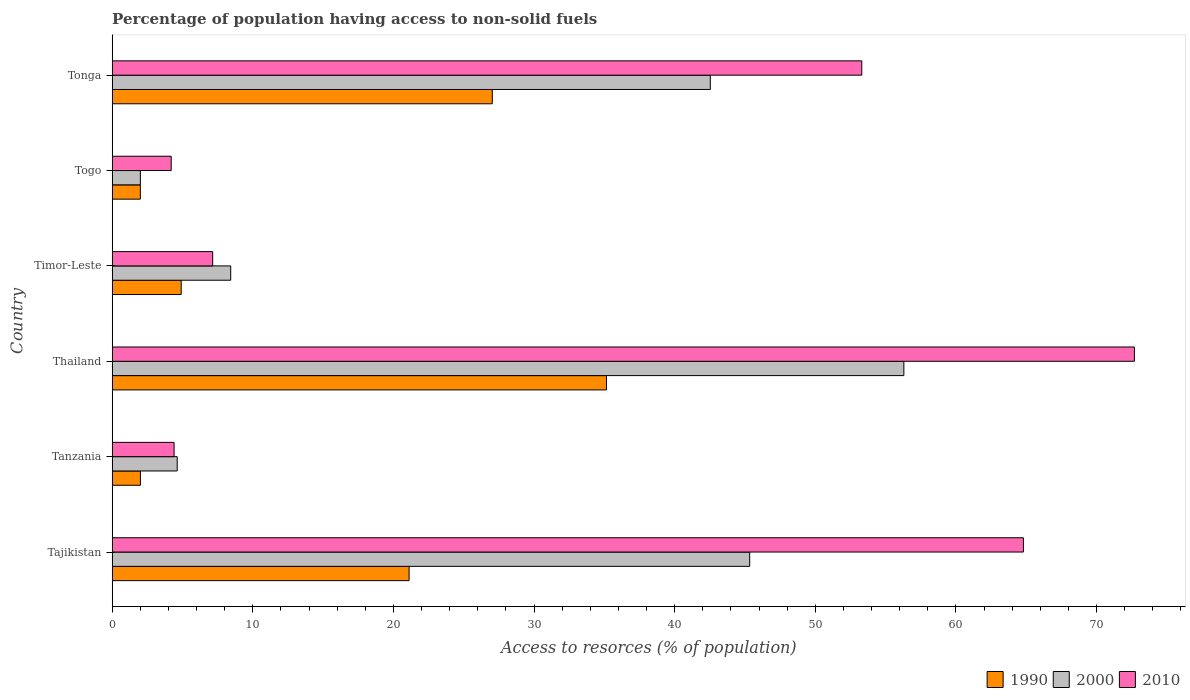How many different coloured bars are there?
Offer a terse response. 3. How many bars are there on the 3rd tick from the top?
Your response must be concise. 3. How many bars are there on the 1st tick from the bottom?
Provide a succinct answer. 3. What is the label of the 5th group of bars from the top?
Give a very brief answer. Tanzania. In how many cases, is the number of bars for a given country not equal to the number of legend labels?
Ensure brevity in your answer.  0. What is the percentage of population having access to non-solid fuels in 2000 in Tonga?
Your response must be concise. 42.54. Across all countries, what is the maximum percentage of population having access to non-solid fuels in 2010?
Make the answer very short. 72.7. Across all countries, what is the minimum percentage of population having access to non-solid fuels in 1990?
Offer a terse response. 2. In which country was the percentage of population having access to non-solid fuels in 1990 maximum?
Your answer should be very brief. Thailand. In which country was the percentage of population having access to non-solid fuels in 2000 minimum?
Keep it short and to the point. Togo. What is the total percentage of population having access to non-solid fuels in 1990 in the graph?
Offer a terse response. 92.2. What is the difference between the percentage of population having access to non-solid fuels in 2010 in Thailand and that in Timor-Leste?
Ensure brevity in your answer.  65.55. What is the difference between the percentage of population having access to non-solid fuels in 1990 in Togo and the percentage of population having access to non-solid fuels in 2000 in Tajikistan?
Provide a succinct answer. -43.34. What is the average percentage of population having access to non-solid fuels in 1990 per country?
Give a very brief answer. 15.37. What is the difference between the percentage of population having access to non-solid fuels in 2000 and percentage of population having access to non-solid fuels in 1990 in Tonga?
Keep it short and to the point. 15.51. In how many countries, is the percentage of population having access to non-solid fuels in 1990 greater than 2 %?
Provide a succinct answer. 5. What is the ratio of the percentage of population having access to non-solid fuels in 2010 in Thailand to that in Togo?
Provide a short and direct response. 17.33. Is the percentage of population having access to non-solid fuels in 2000 in Tajikistan less than that in Tonga?
Your answer should be very brief. No. What is the difference between the highest and the second highest percentage of population having access to non-solid fuels in 1990?
Provide a short and direct response. 8.12. What is the difference between the highest and the lowest percentage of population having access to non-solid fuels in 2010?
Provide a short and direct response. 68.5. In how many countries, is the percentage of population having access to non-solid fuels in 2010 greater than the average percentage of population having access to non-solid fuels in 2010 taken over all countries?
Keep it short and to the point. 3. Is the sum of the percentage of population having access to non-solid fuels in 2000 in Tanzania and Tonga greater than the maximum percentage of population having access to non-solid fuels in 2010 across all countries?
Offer a terse response. No. Is it the case that in every country, the sum of the percentage of population having access to non-solid fuels in 2000 and percentage of population having access to non-solid fuels in 2010 is greater than the percentage of population having access to non-solid fuels in 1990?
Keep it short and to the point. Yes. How many bars are there?
Offer a terse response. 18. Are all the bars in the graph horizontal?
Ensure brevity in your answer.  Yes. What is the difference between two consecutive major ticks on the X-axis?
Keep it short and to the point. 10. Are the values on the major ticks of X-axis written in scientific E-notation?
Your answer should be compact. No. Does the graph contain grids?
Your answer should be compact. No. What is the title of the graph?
Offer a very short reply. Percentage of population having access to non-solid fuels. What is the label or title of the X-axis?
Keep it short and to the point. Access to resorces (% of population). What is the label or title of the Y-axis?
Offer a very short reply. Country. What is the Access to resorces (% of population) of 1990 in Tajikistan?
Offer a very short reply. 21.11. What is the Access to resorces (% of population) in 2000 in Tajikistan?
Offer a terse response. 45.34. What is the Access to resorces (% of population) in 2010 in Tajikistan?
Offer a very short reply. 64.8. What is the Access to resorces (% of population) in 1990 in Tanzania?
Your response must be concise. 2.01. What is the Access to resorces (% of population) of 2000 in Tanzania?
Keep it short and to the point. 4.62. What is the Access to resorces (% of population) in 2010 in Tanzania?
Provide a succinct answer. 4.4. What is the Access to resorces (% of population) of 1990 in Thailand?
Offer a terse response. 35.15. What is the Access to resorces (% of population) in 2000 in Thailand?
Make the answer very short. 56.3. What is the Access to resorces (% of population) in 2010 in Thailand?
Keep it short and to the point. 72.7. What is the Access to resorces (% of population) of 1990 in Timor-Leste?
Make the answer very short. 4.9. What is the Access to resorces (% of population) of 2000 in Timor-Leste?
Make the answer very short. 8.43. What is the Access to resorces (% of population) in 2010 in Timor-Leste?
Offer a terse response. 7.14. What is the Access to resorces (% of population) in 1990 in Togo?
Give a very brief answer. 2. What is the Access to resorces (% of population) in 2000 in Togo?
Keep it short and to the point. 2. What is the Access to resorces (% of population) in 2010 in Togo?
Give a very brief answer. 4.19. What is the Access to resorces (% of population) in 1990 in Tonga?
Your response must be concise. 27.03. What is the Access to resorces (% of population) in 2000 in Tonga?
Offer a very short reply. 42.54. What is the Access to resorces (% of population) in 2010 in Tonga?
Your answer should be very brief. 53.31. Across all countries, what is the maximum Access to resorces (% of population) of 1990?
Offer a terse response. 35.15. Across all countries, what is the maximum Access to resorces (% of population) in 2000?
Keep it short and to the point. 56.3. Across all countries, what is the maximum Access to resorces (% of population) of 2010?
Keep it short and to the point. 72.7. Across all countries, what is the minimum Access to resorces (% of population) of 1990?
Your answer should be compact. 2. Across all countries, what is the minimum Access to resorces (% of population) in 2000?
Your answer should be very brief. 2. Across all countries, what is the minimum Access to resorces (% of population) in 2010?
Your response must be concise. 4.19. What is the total Access to resorces (% of population) of 1990 in the graph?
Offer a terse response. 92.2. What is the total Access to resorces (% of population) in 2000 in the graph?
Keep it short and to the point. 159.22. What is the total Access to resorces (% of population) in 2010 in the graph?
Make the answer very short. 206.54. What is the difference between the Access to resorces (% of population) of 1990 in Tajikistan and that in Tanzania?
Provide a short and direct response. 19.11. What is the difference between the Access to resorces (% of population) of 2000 in Tajikistan and that in Tanzania?
Offer a very short reply. 40.72. What is the difference between the Access to resorces (% of population) of 2010 in Tajikistan and that in Tanzania?
Ensure brevity in your answer.  60.4. What is the difference between the Access to resorces (% of population) of 1990 in Tajikistan and that in Thailand?
Provide a short and direct response. -14.04. What is the difference between the Access to resorces (% of population) of 2000 in Tajikistan and that in Thailand?
Your response must be concise. -10.96. What is the difference between the Access to resorces (% of population) in 2010 in Tajikistan and that in Thailand?
Keep it short and to the point. -7.89. What is the difference between the Access to resorces (% of population) in 1990 in Tajikistan and that in Timor-Leste?
Give a very brief answer. 16.21. What is the difference between the Access to resorces (% of population) of 2000 in Tajikistan and that in Timor-Leste?
Your answer should be very brief. 36.91. What is the difference between the Access to resorces (% of population) in 2010 in Tajikistan and that in Timor-Leste?
Keep it short and to the point. 57.66. What is the difference between the Access to resorces (% of population) in 1990 in Tajikistan and that in Togo?
Offer a terse response. 19.11. What is the difference between the Access to resorces (% of population) of 2000 in Tajikistan and that in Togo?
Your response must be concise. 43.33. What is the difference between the Access to resorces (% of population) of 2010 in Tajikistan and that in Togo?
Your answer should be compact. 60.61. What is the difference between the Access to resorces (% of population) in 1990 in Tajikistan and that in Tonga?
Provide a succinct answer. -5.92. What is the difference between the Access to resorces (% of population) of 2000 in Tajikistan and that in Tonga?
Make the answer very short. 2.8. What is the difference between the Access to resorces (% of population) in 2010 in Tajikistan and that in Tonga?
Offer a very short reply. 11.5. What is the difference between the Access to resorces (% of population) in 1990 in Tanzania and that in Thailand?
Make the answer very short. -33.15. What is the difference between the Access to resorces (% of population) of 2000 in Tanzania and that in Thailand?
Your answer should be very brief. -51.68. What is the difference between the Access to resorces (% of population) of 2010 in Tanzania and that in Thailand?
Give a very brief answer. -68.3. What is the difference between the Access to resorces (% of population) in 1990 in Tanzania and that in Timor-Leste?
Give a very brief answer. -2.9. What is the difference between the Access to resorces (% of population) of 2000 in Tanzania and that in Timor-Leste?
Your answer should be very brief. -3.81. What is the difference between the Access to resorces (% of population) in 2010 in Tanzania and that in Timor-Leste?
Make the answer very short. -2.75. What is the difference between the Access to resorces (% of population) of 1990 in Tanzania and that in Togo?
Your response must be concise. 0.01. What is the difference between the Access to resorces (% of population) in 2000 in Tanzania and that in Togo?
Ensure brevity in your answer.  2.62. What is the difference between the Access to resorces (% of population) of 2010 in Tanzania and that in Togo?
Give a very brief answer. 0.2. What is the difference between the Access to resorces (% of population) of 1990 in Tanzania and that in Tonga?
Keep it short and to the point. -25.02. What is the difference between the Access to resorces (% of population) of 2000 in Tanzania and that in Tonga?
Make the answer very short. -37.92. What is the difference between the Access to resorces (% of population) in 2010 in Tanzania and that in Tonga?
Offer a terse response. -48.91. What is the difference between the Access to resorces (% of population) in 1990 in Thailand and that in Timor-Leste?
Provide a short and direct response. 30.25. What is the difference between the Access to resorces (% of population) of 2000 in Thailand and that in Timor-Leste?
Provide a short and direct response. 47.87. What is the difference between the Access to resorces (% of population) of 2010 in Thailand and that in Timor-Leste?
Offer a terse response. 65.55. What is the difference between the Access to resorces (% of population) in 1990 in Thailand and that in Togo?
Ensure brevity in your answer.  33.15. What is the difference between the Access to resorces (% of population) of 2000 in Thailand and that in Togo?
Provide a short and direct response. 54.3. What is the difference between the Access to resorces (% of population) of 2010 in Thailand and that in Togo?
Make the answer very short. 68.5. What is the difference between the Access to resorces (% of population) in 1990 in Thailand and that in Tonga?
Provide a short and direct response. 8.12. What is the difference between the Access to resorces (% of population) of 2000 in Thailand and that in Tonga?
Make the answer very short. 13.76. What is the difference between the Access to resorces (% of population) of 2010 in Thailand and that in Tonga?
Your answer should be compact. 19.39. What is the difference between the Access to resorces (% of population) of 1990 in Timor-Leste and that in Togo?
Offer a very short reply. 2.9. What is the difference between the Access to resorces (% of population) in 2000 in Timor-Leste and that in Togo?
Keep it short and to the point. 6.43. What is the difference between the Access to resorces (% of population) in 2010 in Timor-Leste and that in Togo?
Your answer should be very brief. 2.95. What is the difference between the Access to resorces (% of population) in 1990 in Timor-Leste and that in Tonga?
Keep it short and to the point. -22.13. What is the difference between the Access to resorces (% of population) in 2000 in Timor-Leste and that in Tonga?
Ensure brevity in your answer.  -34.11. What is the difference between the Access to resorces (% of population) in 2010 in Timor-Leste and that in Tonga?
Make the answer very short. -46.16. What is the difference between the Access to resorces (% of population) of 1990 in Togo and that in Tonga?
Your response must be concise. -25.03. What is the difference between the Access to resorces (% of population) of 2000 in Togo and that in Tonga?
Offer a terse response. -40.54. What is the difference between the Access to resorces (% of population) in 2010 in Togo and that in Tonga?
Your response must be concise. -49.11. What is the difference between the Access to resorces (% of population) in 1990 in Tajikistan and the Access to resorces (% of population) in 2000 in Tanzania?
Ensure brevity in your answer.  16.49. What is the difference between the Access to resorces (% of population) in 1990 in Tajikistan and the Access to resorces (% of population) in 2010 in Tanzania?
Your response must be concise. 16.71. What is the difference between the Access to resorces (% of population) of 2000 in Tajikistan and the Access to resorces (% of population) of 2010 in Tanzania?
Give a very brief answer. 40.94. What is the difference between the Access to resorces (% of population) of 1990 in Tajikistan and the Access to resorces (% of population) of 2000 in Thailand?
Provide a short and direct response. -35.19. What is the difference between the Access to resorces (% of population) of 1990 in Tajikistan and the Access to resorces (% of population) of 2010 in Thailand?
Offer a very short reply. -51.58. What is the difference between the Access to resorces (% of population) of 2000 in Tajikistan and the Access to resorces (% of population) of 2010 in Thailand?
Make the answer very short. -27.36. What is the difference between the Access to resorces (% of population) of 1990 in Tajikistan and the Access to resorces (% of population) of 2000 in Timor-Leste?
Make the answer very short. 12.69. What is the difference between the Access to resorces (% of population) in 1990 in Tajikistan and the Access to resorces (% of population) in 2010 in Timor-Leste?
Your response must be concise. 13.97. What is the difference between the Access to resorces (% of population) in 2000 in Tajikistan and the Access to resorces (% of population) in 2010 in Timor-Leste?
Offer a very short reply. 38.19. What is the difference between the Access to resorces (% of population) in 1990 in Tajikistan and the Access to resorces (% of population) in 2000 in Togo?
Provide a short and direct response. 19.11. What is the difference between the Access to resorces (% of population) in 1990 in Tajikistan and the Access to resorces (% of population) in 2010 in Togo?
Provide a succinct answer. 16.92. What is the difference between the Access to resorces (% of population) of 2000 in Tajikistan and the Access to resorces (% of population) of 2010 in Togo?
Offer a terse response. 41.14. What is the difference between the Access to resorces (% of population) of 1990 in Tajikistan and the Access to resorces (% of population) of 2000 in Tonga?
Offer a very short reply. -21.42. What is the difference between the Access to resorces (% of population) of 1990 in Tajikistan and the Access to resorces (% of population) of 2010 in Tonga?
Offer a terse response. -32.2. What is the difference between the Access to resorces (% of population) in 2000 in Tajikistan and the Access to resorces (% of population) in 2010 in Tonga?
Offer a very short reply. -7.97. What is the difference between the Access to resorces (% of population) in 1990 in Tanzania and the Access to resorces (% of population) in 2000 in Thailand?
Offer a very short reply. -54.3. What is the difference between the Access to resorces (% of population) in 1990 in Tanzania and the Access to resorces (% of population) in 2010 in Thailand?
Offer a terse response. -70.69. What is the difference between the Access to resorces (% of population) of 2000 in Tanzania and the Access to resorces (% of population) of 2010 in Thailand?
Your answer should be compact. -68.08. What is the difference between the Access to resorces (% of population) of 1990 in Tanzania and the Access to resorces (% of population) of 2000 in Timor-Leste?
Offer a terse response. -6.42. What is the difference between the Access to resorces (% of population) of 1990 in Tanzania and the Access to resorces (% of population) of 2010 in Timor-Leste?
Provide a succinct answer. -5.14. What is the difference between the Access to resorces (% of population) in 2000 in Tanzania and the Access to resorces (% of population) in 2010 in Timor-Leste?
Your answer should be compact. -2.52. What is the difference between the Access to resorces (% of population) in 1990 in Tanzania and the Access to resorces (% of population) in 2000 in Togo?
Provide a succinct answer. 0. What is the difference between the Access to resorces (% of population) in 1990 in Tanzania and the Access to resorces (% of population) in 2010 in Togo?
Keep it short and to the point. -2.19. What is the difference between the Access to resorces (% of population) in 2000 in Tanzania and the Access to resorces (% of population) in 2010 in Togo?
Provide a short and direct response. 0.43. What is the difference between the Access to resorces (% of population) in 1990 in Tanzania and the Access to resorces (% of population) in 2000 in Tonga?
Make the answer very short. -40.53. What is the difference between the Access to resorces (% of population) of 1990 in Tanzania and the Access to resorces (% of population) of 2010 in Tonga?
Your answer should be compact. -51.3. What is the difference between the Access to resorces (% of population) in 2000 in Tanzania and the Access to resorces (% of population) in 2010 in Tonga?
Give a very brief answer. -48.69. What is the difference between the Access to resorces (% of population) of 1990 in Thailand and the Access to resorces (% of population) of 2000 in Timor-Leste?
Provide a succinct answer. 26.72. What is the difference between the Access to resorces (% of population) of 1990 in Thailand and the Access to resorces (% of population) of 2010 in Timor-Leste?
Make the answer very short. 28.01. What is the difference between the Access to resorces (% of population) of 2000 in Thailand and the Access to resorces (% of population) of 2010 in Timor-Leste?
Offer a terse response. 49.16. What is the difference between the Access to resorces (% of population) in 1990 in Thailand and the Access to resorces (% of population) in 2000 in Togo?
Give a very brief answer. 33.15. What is the difference between the Access to resorces (% of population) of 1990 in Thailand and the Access to resorces (% of population) of 2010 in Togo?
Provide a succinct answer. 30.96. What is the difference between the Access to resorces (% of population) of 2000 in Thailand and the Access to resorces (% of population) of 2010 in Togo?
Provide a short and direct response. 52.11. What is the difference between the Access to resorces (% of population) in 1990 in Thailand and the Access to resorces (% of population) in 2000 in Tonga?
Make the answer very short. -7.39. What is the difference between the Access to resorces (% of population) of 1990 in Thailand and the Access to resorces (% of population) of 2010 in Tonga?
Your answer should be very brief. -18.16. What is the difference between the Access to resorces (% of population) in 2000 in Thailand and the Access to resorces (% of population) in 2010 in Tonga?
Provide a short and direct response. 2.99. What is the difference between the Access to resorces (% of population) in 1990 in Timor-Leste and the Access to resorces (% of population) in 2000 in Togo?
Give a very brief answer. 2.9. What is the difference between the Access to resorces (% of population) in 1990 in Timor-Leste and the Access to resorces (% of population) in 2010 in Togo?
Provide a succinct answer. 0.71. What is the difference between the Access to resorces (% of population) in 2000 in Timor-Leste and the Access to resorces (% of population) in 2010 in Togo?
Provide a succinct answer. 4.23. What is the difference between the Access to resorces (% of population) in 1990 in Timor-Leste and the Access to resorces (% of population) in 2000 in Tonga?
Your answer should be compact. -37.63. What is the difference between the Access to resorces (% of population) of 1990 in Timor-Leste and the Access to resorces (% of population) of 2010 in Tonga?
Provide a short and direct response. -48.4. What is the difference between the Access to resorces (% of population) of 2000 in Timor-Leste and the Access to resorces (% of population) of 2010 in Tonga?
Make the answer very short. -44.88. What is the difference between the Access to resorces (% of population) of 1990 in Togo and the Access to resorces (% of population) of 2000 in Tonga?
Your answer should be very brief. -40.54. What is the difference between the Access to resorces (% of population) of 1990 in Togo and the Access to resorces (% of population) of 2010 in Tonga?
Ensure brevity in your answer.  -51.31. What is the difference between the Access to resorces (% of population) of 2000 in Togo and the Access to resorces (% of population) of 2010 in Tonga?
Ensure brevity in your answer.  -51.31. What is the average Access to resorces (% of population) of 1990 per country?
Offer a terse response. 15.37. What is the average Access to resorces (% of population) of 2000 per country?
Offer a terse response. 26.54. What is the average Access to resorces (% of population) of 2010 per country?
Offer a very short reply. 34.42. What is the difference between the Access to resorces (% of population) in 1990 and Access to resorces (% of population) in 2000 in Tajikistan?
Provide a short and direct response. -24.22. What is the difference between the Access to resorces (% of population) of 1990 and Access to resorces (% of population) of 2010 in Tajikistan?
Your response must be concise. -43.69. What is the difference between the Access to resorces (% of population) in 2000 and Access to resorces (% of population) in 2010 in Tajikistan?
Ensure brevity in your answer.  -19.47. What is the difference between the Access to resorces (% of population) of 1990 and Access to resorces (% of population) of 2000 in Tanzania?
Your answer should be very brief. -2.62. What is the difference between the Access to resorces (% of population) in 1990 and Access to resorces (% of population) in 2010 in Tanzania?
Offer a terse response. -2.39. What is the difference between the Access to resorces (% of population) of 2000 and Access to resorces (% of population) of 2010 in Tanzania?
Your answer should be compact. 0.22. What is the difference between the Access to resorces (% of population) in 1990 and Access to resorces (% of population) in 2000 in Thailand?
Provide a succinct answer. -21.15. What is the difference between the Access to resorces (% of population) of 1990 and Access to resorces (% of population) of 2010 in Thailand?
Provide a succinct answer. -37.54. What is the difference between the Access to resorces (% of population) in 2000 and Access to resorces (% of population) in 2010 in Thailand?
Make the answer very short. -16.39. What is the difference between the Access to resorces (% of population) of 1990 and Access to resorces (% of population) of 2000 in Timor-Leste?
Provide a short and direct response. -3.52. What is the difference between the Access to resorces (% of population) of 1990 and Access to resorces (% of population) of 2010 in Timor-Leste?
Provide a succinct answer. -2.24. What is the difference between the Access to resorces (% of population) in 2000 and Access to resorces (% of population) in 2010 in Timor-Leste?
Make the answer very short. 1.28. What is the difference between the Access to resorces (% of population) of 1990 and Access to resorces (% of population) of 2000 in Togo?
Provide a succinct answer. -0. What is the difference between the Access to resorces (% of population) in 1990 and Access to resorces (% of population) in 2010 in Togo?
Provide a succinct answer. -2.19. What is the difference between the Access to resorces (% of population) of 2000 and Access to resorces (% of population) of 2010 in Togo?
Your answer should be very brief. -2.19. What is the difference between the Access to resorces (% of population) in 1990 and Access to resorces (% of population) in 2000 in Tonga?
Provide a succinct answer. -15.51. What is the difference between the Access to resorces (% of population) in 1990 and Access to resorces (% of population) in 2010 in Tonga?
Your answer should be very brief. -26.28. What is the difference between the Access to resorces (% of population) in 2000 and Access to resorces (% of population) in 2010 in Tonga?
Offer a very short reply. -10.77. What is the ratio of the Access to resorces (% of population) in 1990 in Tajikistan to that in Tanzania?
Ensure brevity in your answer.  10.53. What is the ratio of the Access to resorces (% of population) of 2000 in Tajikistan to that in Tanzania?
Ensure brevity in your answer.  9.81. What is the ratio of the Access to resorces (% of population) in 2010 in Tajikistan to that in Tanzania?
Make the answer very short. 14.73. What is the ratio of the Access to resorces (% of population) of 1990 in Tajikistan to that in Thailand?
Give a very brief answer. 0.6. What is the ratio of the Access to resorces (% of population) in 2000 in Tajikistan to that in Thailand?
Ensure brevity in your answer.  0.81. What is the ratio of the Access to resorces (% of population) in 2010 in Tajikistan to that in Thailand?
Provide a succinct answer. 0.89. What is the ratio of the Access to resorces (% of population) in 1990 in Tajikistan to that in Timor-Leste?
Your answer should be very brief. 4.31. What is the ratio of the Access to resorces (% of population) in 2000 in Tajikistan to that in Timor-Leste?
Keep it short and to the point. 5.38. What is the ratio of the Access to resorces (% of population) of 2010 in Tajikistan to that in Timor-Leste?
Give a very brief answer. 9.07. What is the ratio of the Access to resorces (% of population) of 1990 in Tajikistan to that in Togo?
Ensure brevity in your answer.  10.56. What is the ratio of the Access to resorces (% of population) of 2000 in Tajikistan to that in Togo?
Your response must be concise. 22.66. What is the ratio of the Access to resorces (% of population) in 2010 in Tajikistan to that in Togo?
Give a very brief answer. 15.45. What is the ratio of the Access to resorces (% of population) in 1990 in Tajikistan to that in Tonga?
Offer a terse response. 0.78. What is the ratio of the Access to resorces (% of population) in 2000 in Tajikistan to that in Tonga?
Your response must be concise. 1.07. What is the ratio of the Access to resorces (% of population) in 2010 in Tajikistan to that in Tonga?
Your answer should be compact. 1.22. What is the ratio of the Access to resorces (% of population) of 1990 in Tanzania to that in Thailand?
Ensure brevity in your answer.  0.06. What is the ratio of the Access to resorces (% of population) of 2000 in Tanzania to that in Thailand?
Your response must be concise. 0.08. What is the ratio of the Access to resorces (% of population) in 2010 in Tanzania to that in Thailand?
Your answer should be compact. 0.06. What is the ratio of the Access to resorces (% of population) in 1990 in Tanzania to that in Timor-Leste?
Give a very brief answer. 0.41. What is the ratio of the Access to resorces (% of population) in 2000 in Tanzania to that in Timor-Leste?
Your answer should be very brief. 0.55. What is the ratio of the Access to resorces (% of population) in 2010 in Tanzania to that in Timor-Leste?
Make the answer very short. 0.62. What is the ratio of the Access to resorces (% of population) in 2000 in Tanzania to that in Togo?
Offer a very short reply. 2.31. What is the ratio of the Access to resorces (% of population) of 2010 in Tanzania to that in Togo?
Offer a terse response. 1.05. What is the ratio of the Access to resorces (% of population) in 1990 in Tanzania to that in Tonga?
Provide a short and direct response. 0.07. What is the ratio of the Access to resorces (% of population) of 2000 in Tanzania to that in Tonga?
Offer a terse response. 0.11. What is the ratio of the Access to resorces (% of population) of 2010 in Tanzania to that in Tonga?
Your answer should be very brief. 0.08. What is the ratio of the Access to resorces (% of population) in 1990 in Thailand to that in Timor-Leste?
Ensure brevity in your answer.  7.17. What is the ratio of the Access to resorces (% of population) of 2000 in Thailand to that in Timor-Leste?
Your answer should be very brief. 6.68. What is the ratio of the Access to resorces (% of population) of 2010 in Thailand to that in Timor-Leste?
Ensure brevity in your answer.  10.18. What is the ratio of the Access to resorces (% of population) of 1990 in Thailand to that in Togo?
Provide a succinct answer. 17.58. What is the ratio of the Access to resorces (% of population) in 2000 in Thailand to that in Togo?
Make the answer very short. 28.14. What is the ratio of the Access to resorces (% of population) in 2010 in Thailand to that in Togo?
Offer a terse response. 17.33. What is the ratio of the Access to resorces (% of population) of 1990 in Thailand to that in Tonga?
Make the answer very short. 1.3. What is the ratio of the Access to resorces (% of population) of 2000 in Thailand to that in Tonga?
Keep it short and to the point. 1.32. What is the ratio of the Access to resorces (% of population) in 2010 in Thailand to that in Tonga?
Offer a very short reply. 1.36. What is the ratio of the Access to resorces (% of population) in 1990 in Timor-Leste to that in Togo?
Ensure brevity in your answer.  2.45. What is the ratio of the Access to resorces (% of population) of 2000 in Timor-Leste to that in Togo?
Ensure brevity in your answer.  4.21. What is the ratio of the Access to resorces (% of population) in 2010 in Timor-Leste to that in Togo?
Your answer should be compact. 1.7. What is the ratio of the Access to resorces (% of population) of 1990 in Timor-Leste to that in Tonga?
Make the answer very short. 0.18. What is the ratio of the Access to resorces (% of population) of 2000 in Timor-Leste to that in Tonga?
Your response must be concise. 0.2. What is the ratio of the Access to resorces (% of population) in 2010 in Timor-Leste to that in Tonga?
Your answer should be compact. 0.13. What is the ratio of the Access to resorces (% of population) of 1990 in Togo to that in Tonga?
Provide a short and direct response. 0.07. What is the ratio of the Access to resorces (% of population) of 2000 in Togo to that in Tonga?
Your answer should be compact. 0.05. What is the ratio of the Access to resorces (% of population) of 2010 in Togo to that in Tonga?
Give a very brief answer. 0.08. What is the difference between the highest and the second highest Access to resorces (% of population) of 1990?
Your answer should be compact. 8.12. What is the difference between the highest and the second highest Access to resorces (% of population) of 2000?
Make the answer very short. 10.96. What is the difference between the highest and the second highest Access to resorces (% of population) in 2010?
Your answer should be compact. 7.89. What is the difference between the highest and the lowest Access to resorces (% of population) of 1990?
Give a very brief answer. 33.15. What is the difference between the highest and the lowest Access to resorces (% of population) in 2000?
Your answer should be very brief. 54.3. What is the difference between the highest and the lowest Access to resorces (% of population) in 2010?
Your answer should be compact. 68.5. 